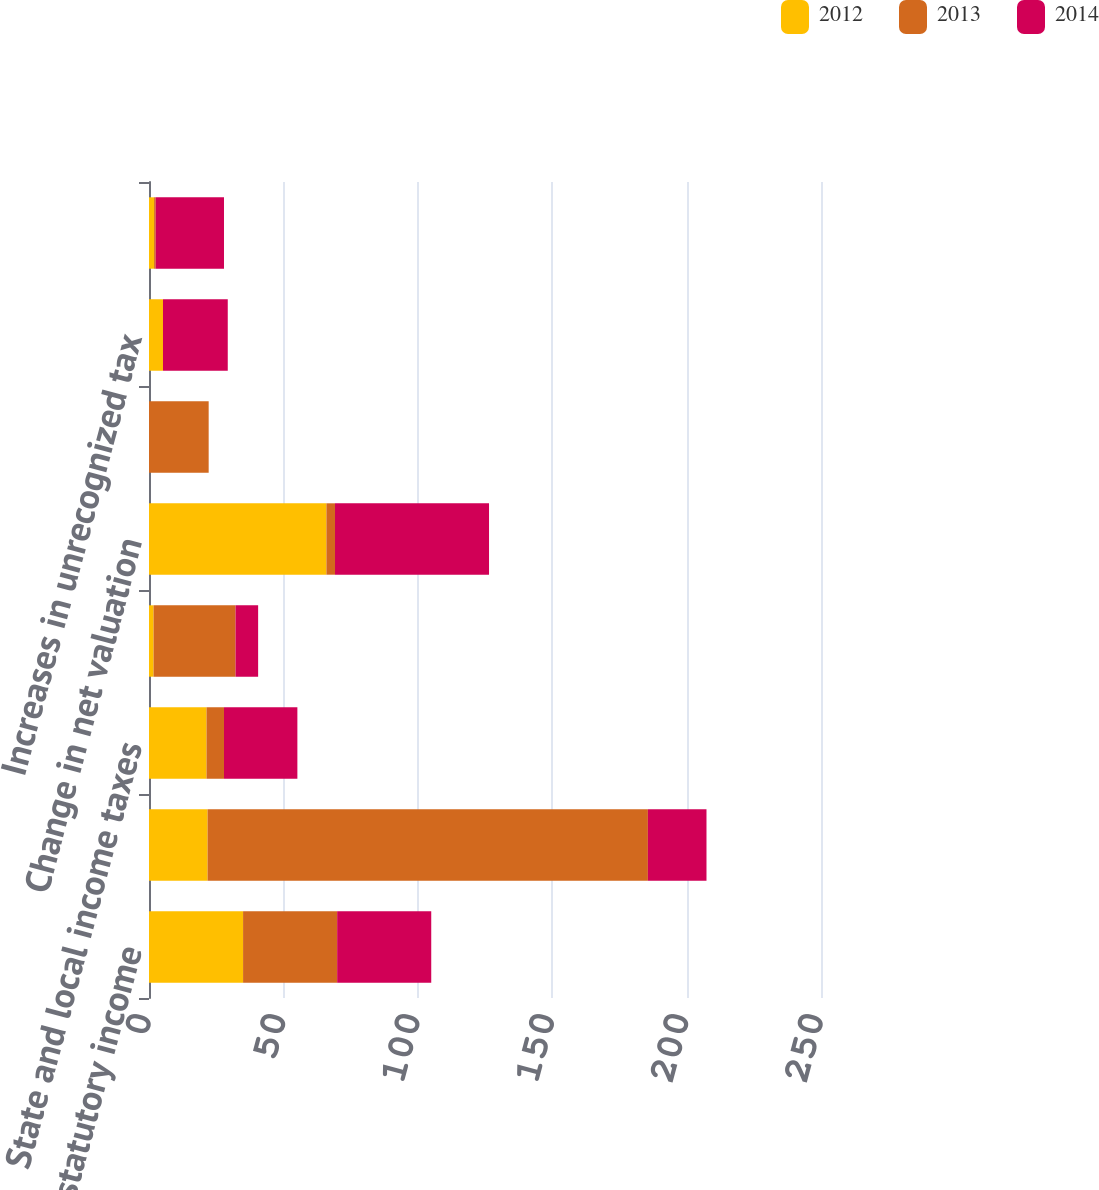Convert chart to OTSL. <chart><loc_0><loc_0><loc_500><loc_500><stacked_bar_chart><ecel><fcel>US federal statutory income<fcel>Income tax provision at US<fcel>State and local income taxes<fcel>Impact of foreign operations<fcel>Change in net valuation<fcel>Worthless securities deduction<fcel>Increases in unrecognized tax<fcel>Other<nl><fcel>2012<fcel>35<fcel>21.8<fcel>21.4<fcel>1.7<fcel>66<fcel>0<fcel>5.2<fcel>1.9<nl><fcel>2013<fcel>35<fcel>163.8<fcel>6.5<fcel>30.5<fcel>3.2<fcel>22.2<fcel>0<fcel>0.6<nl><fcel>2014<fcel>35<fcel>21.8<fcel>27.3<fcel>8.4<fcel>57.3<fcel>0<fcel>24.1<fcel>25.4<nl></chart> 